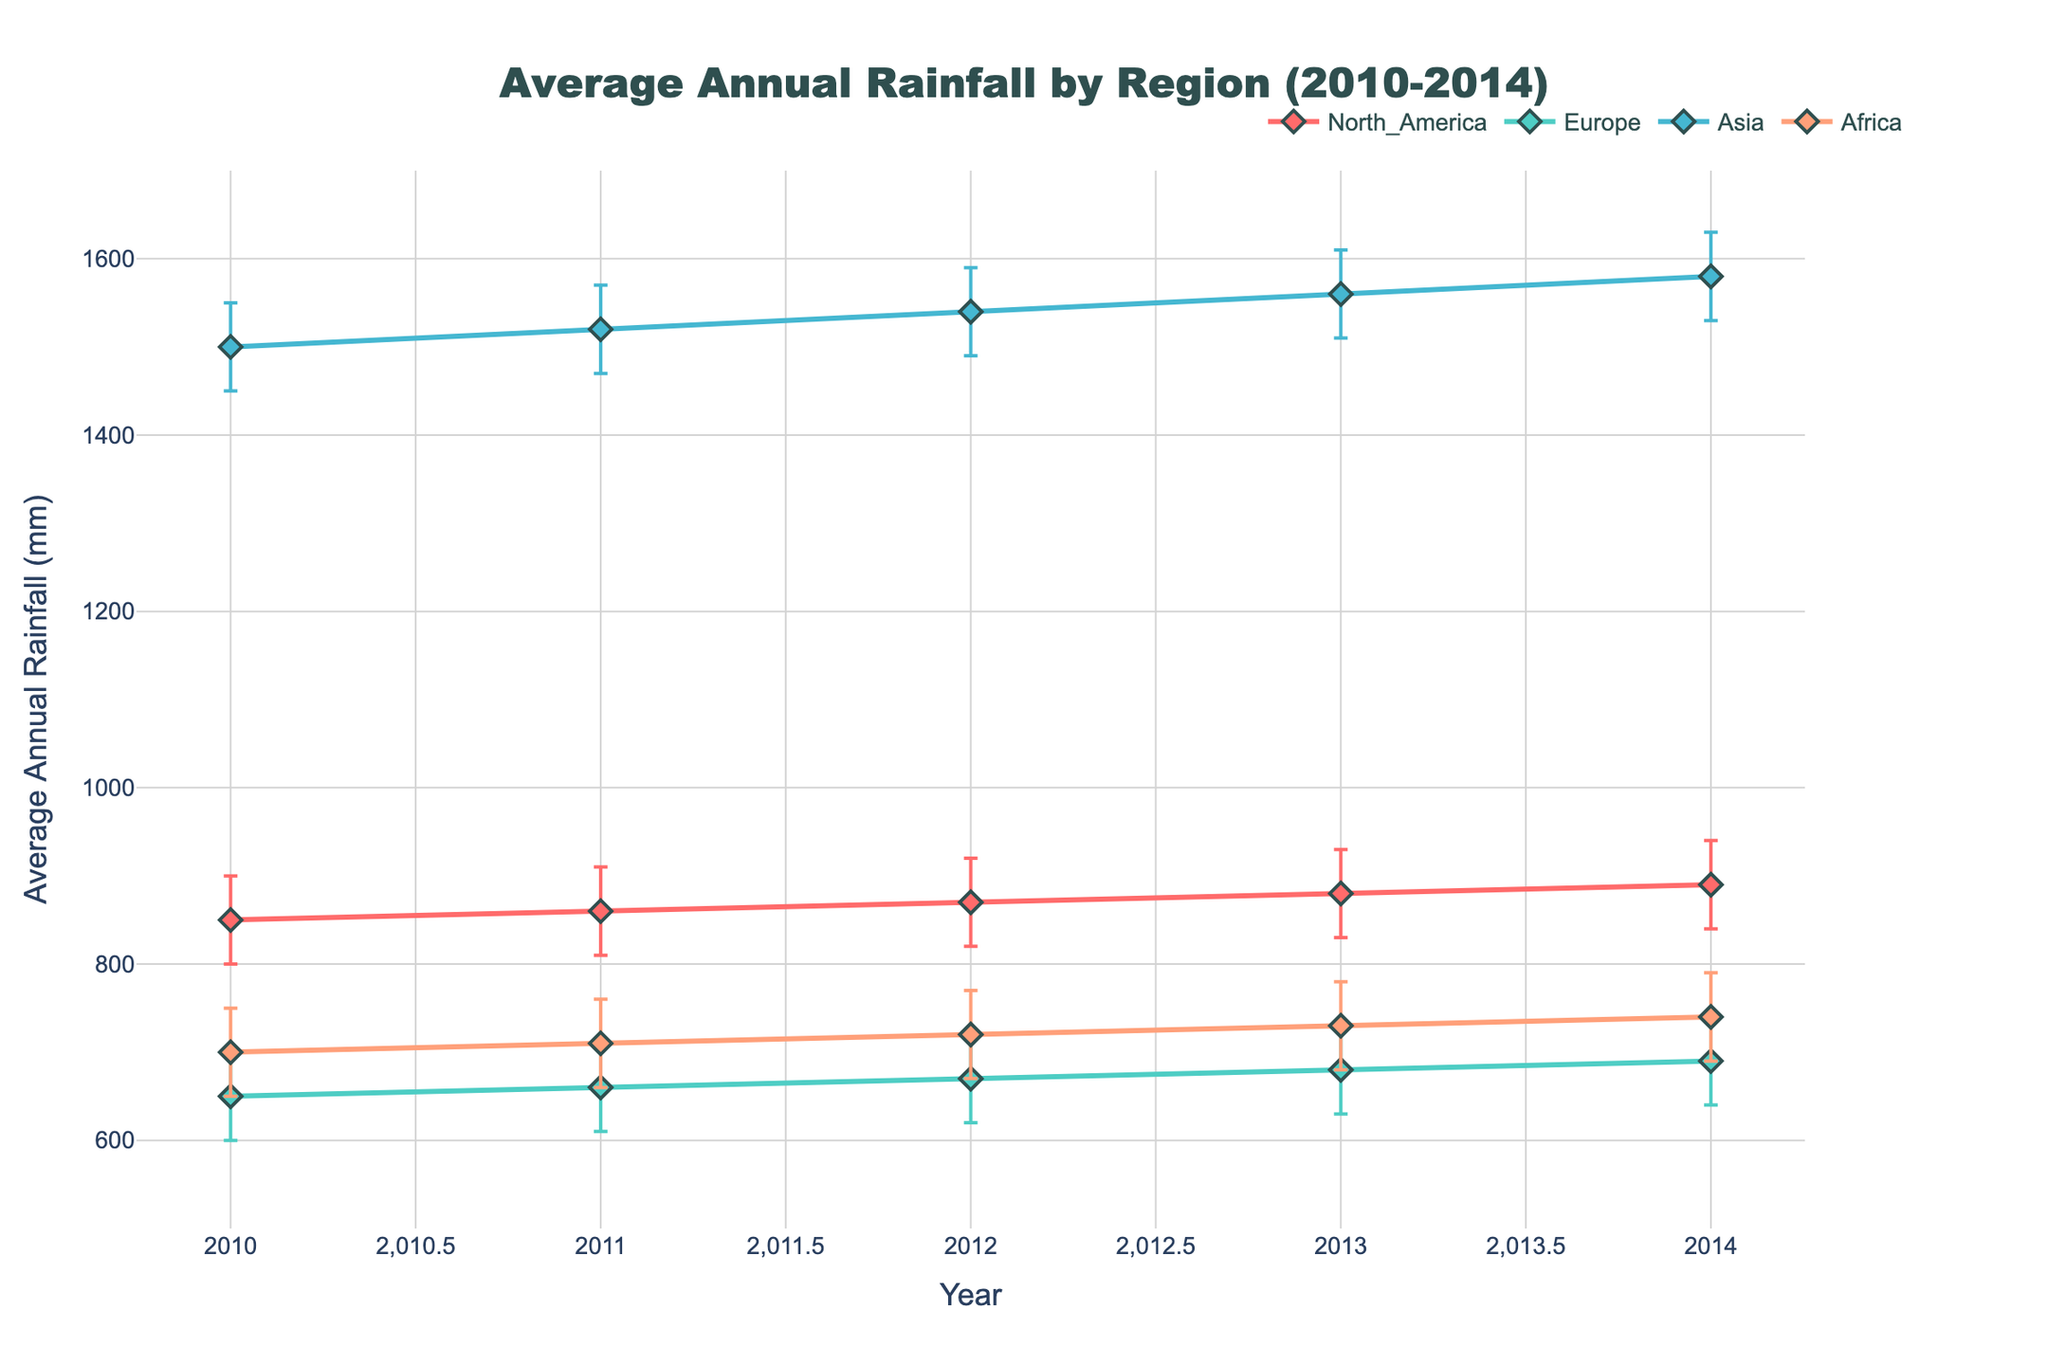What is the title of the plot? The plot's title is located at the top center. The title is "Average Annual Rainfall by Region (2010-2014)".
Answer: Average Annual Rainfall by Region (2010-2014) Which year had the highest average annual rainfall in Asia? By examining the line plot for Asia, the peak occurs in 2014.
Answer: 2014 Which region has the lowest average annual rainfall in 2013? To find the lowest value for 2013, compare the data points for all regions in that year. Europe shows the lowest average annual rainfall in 2013.
Answer: Europe What is the range of average annual rainfall values for North America from 2010 to 2014? Ranges can be found by comparing the minimum and maximum average annual rainfall values over the years. For North America, the minimum is 850 mm (2010) and the maximum is 890 mm (2014). The range is 890 - 850 mm.
Answer: 40 mm By how much did the average annual rainfall change in Africa from 2011 to 2014? Look at the data points for Africa in 2011 and 2014. In 2011, the average annual rainfall is 710 mm, and in 2014, it is 740 mm. The change is 740 mm - 710 mm.
Answer: 30 mm Which region consistently experienced the highest average annual rainfall during the period 2010-2014? Compare the trends of the different regions across the years. Asia consistently has higher average annual rainfall throughout all years.
Answer: Asia What is the uncertainty interval for Europe in 2012? The uncertainty interval is represented by the error bars. For Europe in 2012, the interval spans from 620 mm to 720 mm.
Answer: 620 mm to 720 mm For which region is the difference between the upper and lower uncertainty bounds the largest in 2014? Calculate the differences for each region in 2014. North America (940-840 = 100 mm), Europe (740-640 = 100 mm), Asia (1630-1530 = 100 mm), Africa (790-690 = 100 mm). All regions have the same difference.
Answer: All regions Compare the average annual rainfall between North America and Europe in 2010. Which is higher and by how much? Find the values for both regions in 2010: North America (850 mm) and Europe (650 mm). Compare these values: 850 mm - 650 mm.
Answer: North America is higher by 200 mm Calculate the average annual rainfall for Asia across all five years. Sum the average annual rainfall for Asia from 2010 to 2014 (1500 mm + 1520 mm + 1540 mm + 1560 mm + 1580 mm) and divide by 5. (1500 + 1520 + 1540 + 1560 + 1580) / 5 = 1540 mm.
Answer: 1540 mm 